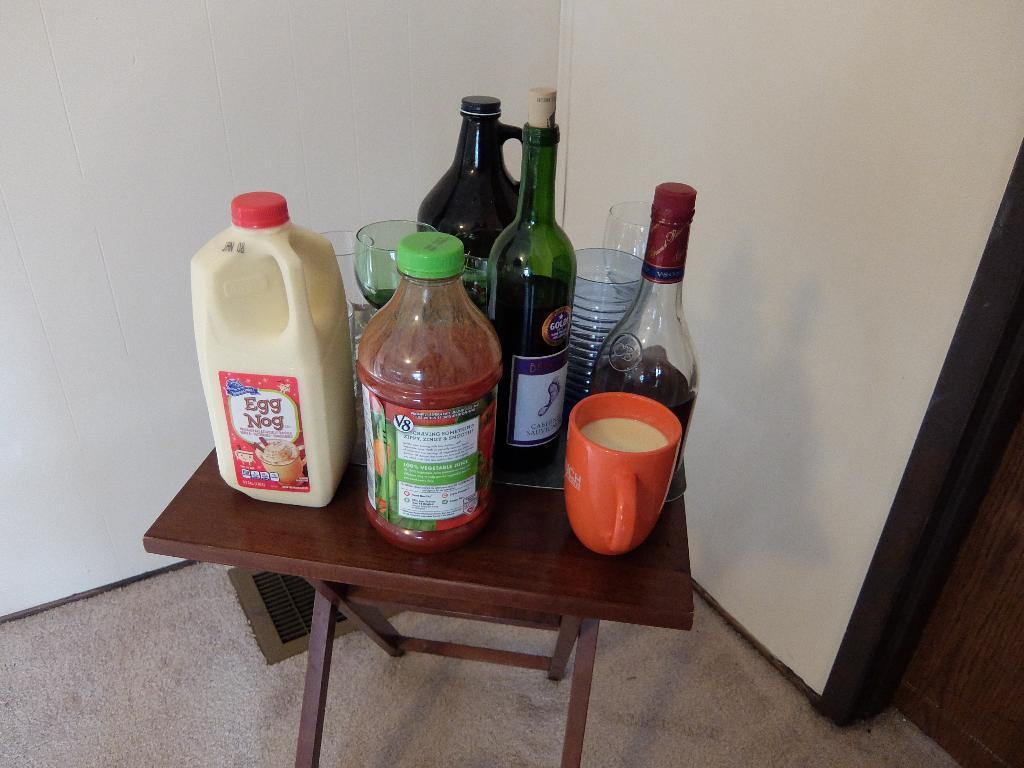In one or two sentences, can you explain what this image depicts? In the image we can see there is a table on which there is a cup, wine bottles, juice bottle, wine glass and there is a bottle on which it's written "Eggnog". 